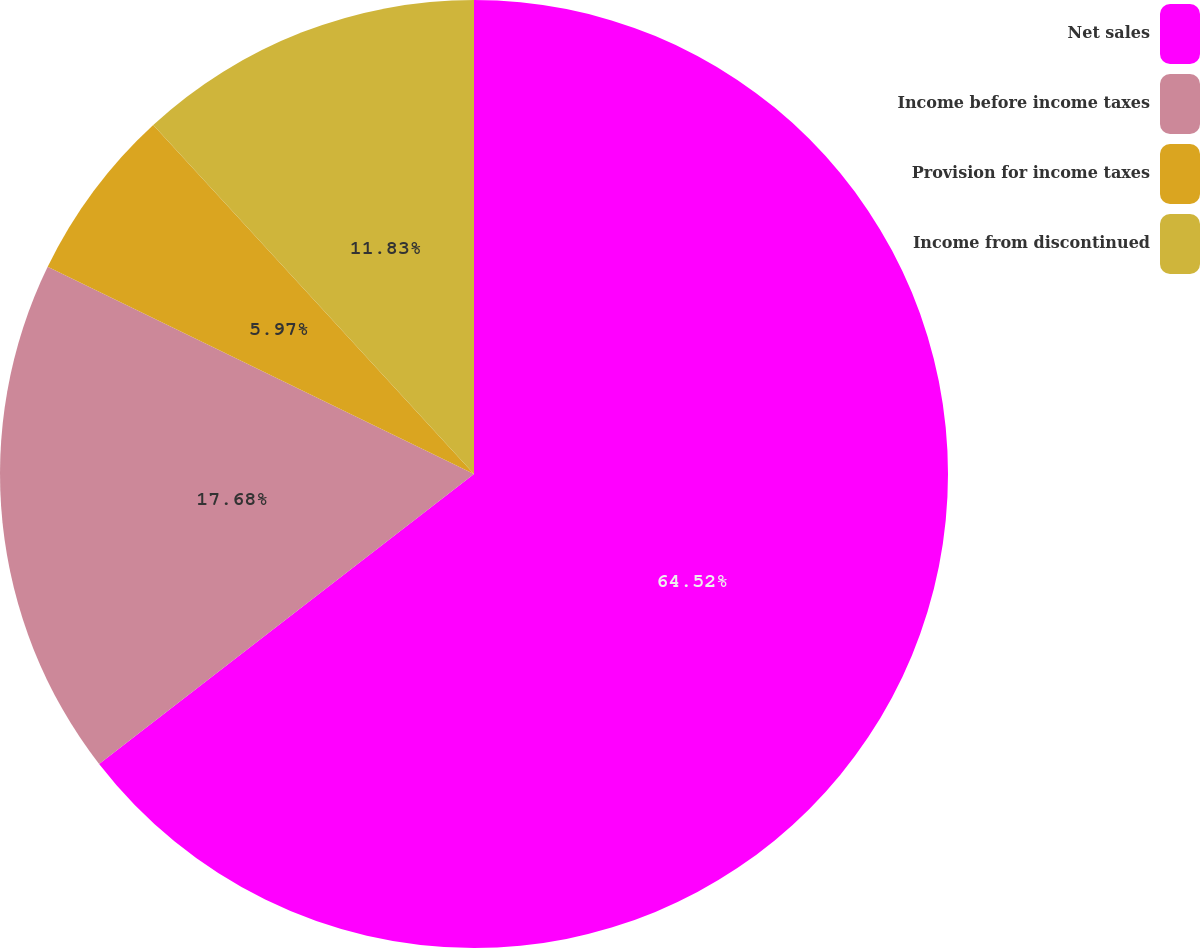<chart> <loc_0><loc_0><loc_500><loc_500><pie_chart><fcel>Net sales<fcel>Income before income taxes<fcel>Provision for income taxes<fcel>Income from discontinued<nl><fcel>64.52%<fcel>17.68%<fcel>5.97%<fcel>11.83%<nl></chart> 